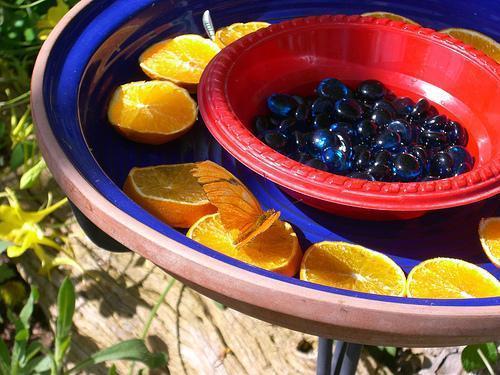How many butterflies are in the picture?
Give a very brief answer. 1. 